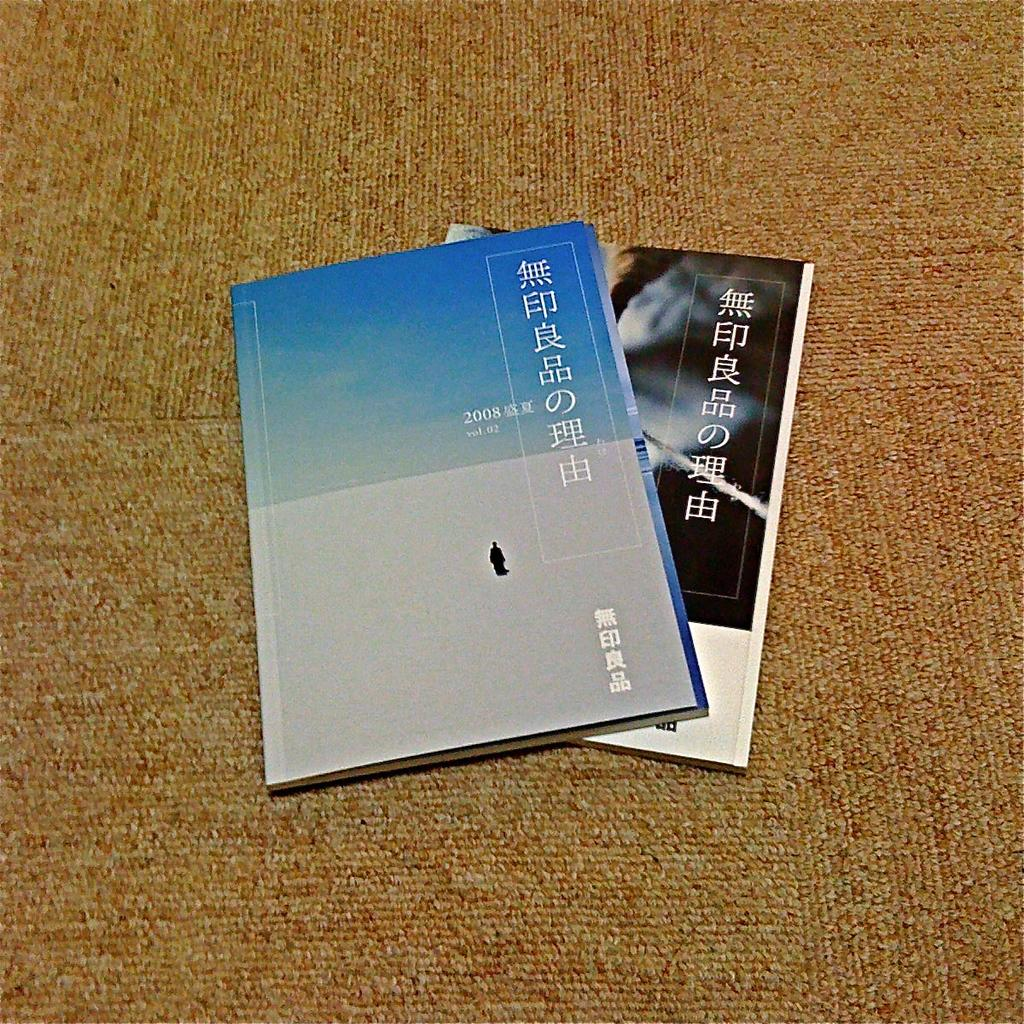<image>
Present a compact description of the photo's key features. A gray and blue book has the year 2008 on it. 